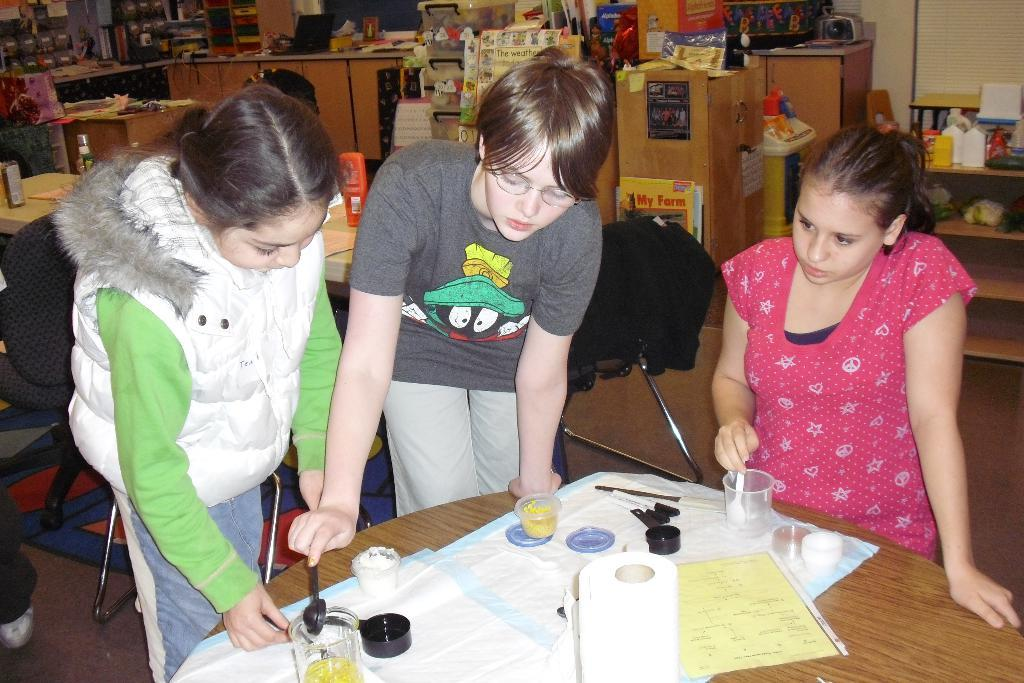How many people are present in the image? There are 3 people standing in the image. What objects are in front of the people? There is a glass, a cup, a paper, a tissue roll, and a spoon in front of the people. What can be seen behind the people? There are cupboards and books behind the people. What type of canvas is being used by the creator in the image? There is no canvas or creator present in the image. Is the image depicting a prison scene? There is no indication in the image that suggests it is a prison scene. 